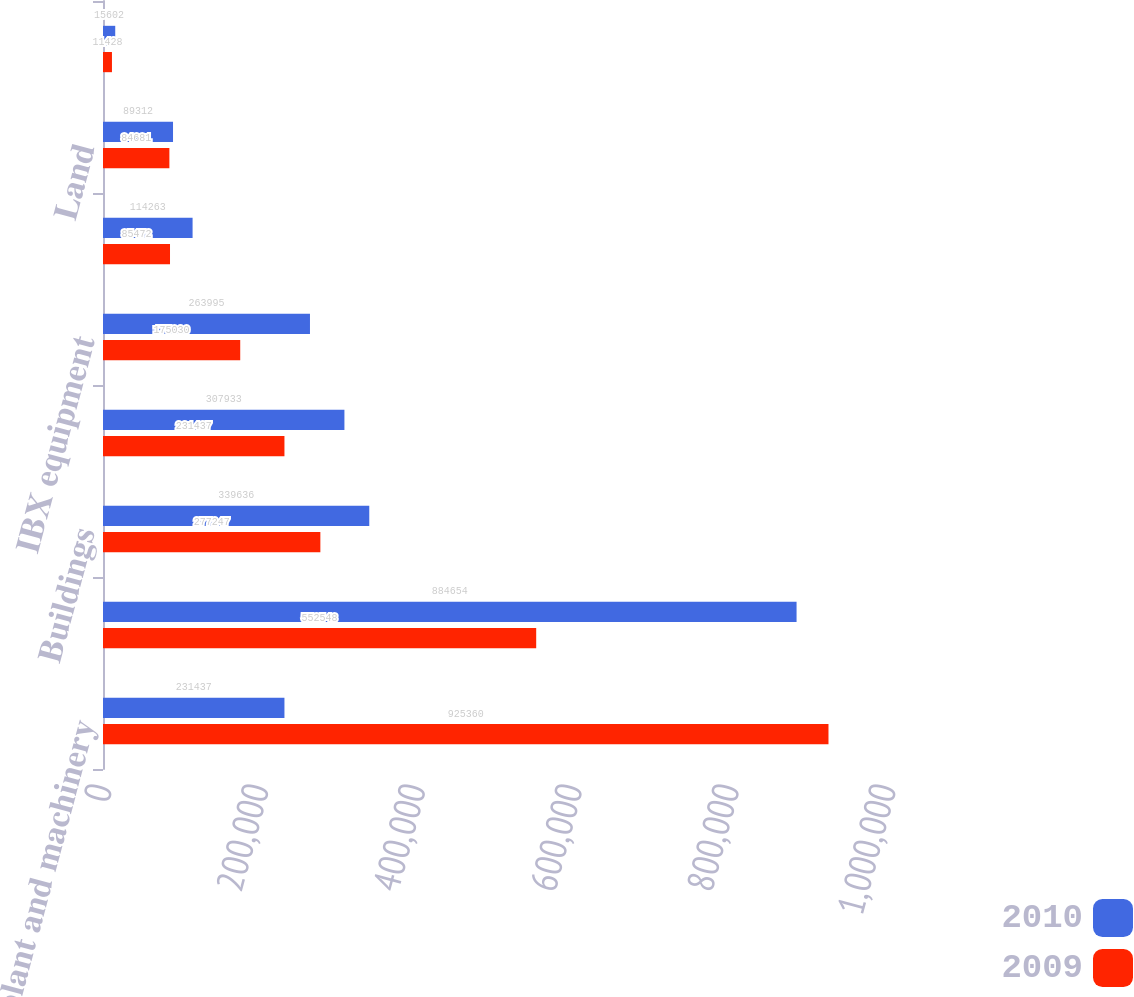Convert chart to OTSL. <chart><loc_0><loc_0><loc_500><loc_500><stacked_bar_chart><ecel><fcel>IBX plant and machinery<fcel>Leasehold improvements<fcel>Buildings<fcel>Site improvements<fcel>IBX equipment<fcel>Computer equipment and<fcel>Land<fcel>Furniture and fixtures<nl><fcel>2010<fcel>231437<fcel>884654<fcel>339636<fcel>307933<fcel>263995<fcel>114263<fcel>89312<fcel>15602<nl><fcel>2009<fcel>925360<fcel>552548<fcel>277247<fcel>231437<fcel>175030<fcel>85472<fcel>84681<fcel>11428<nl></chart> 